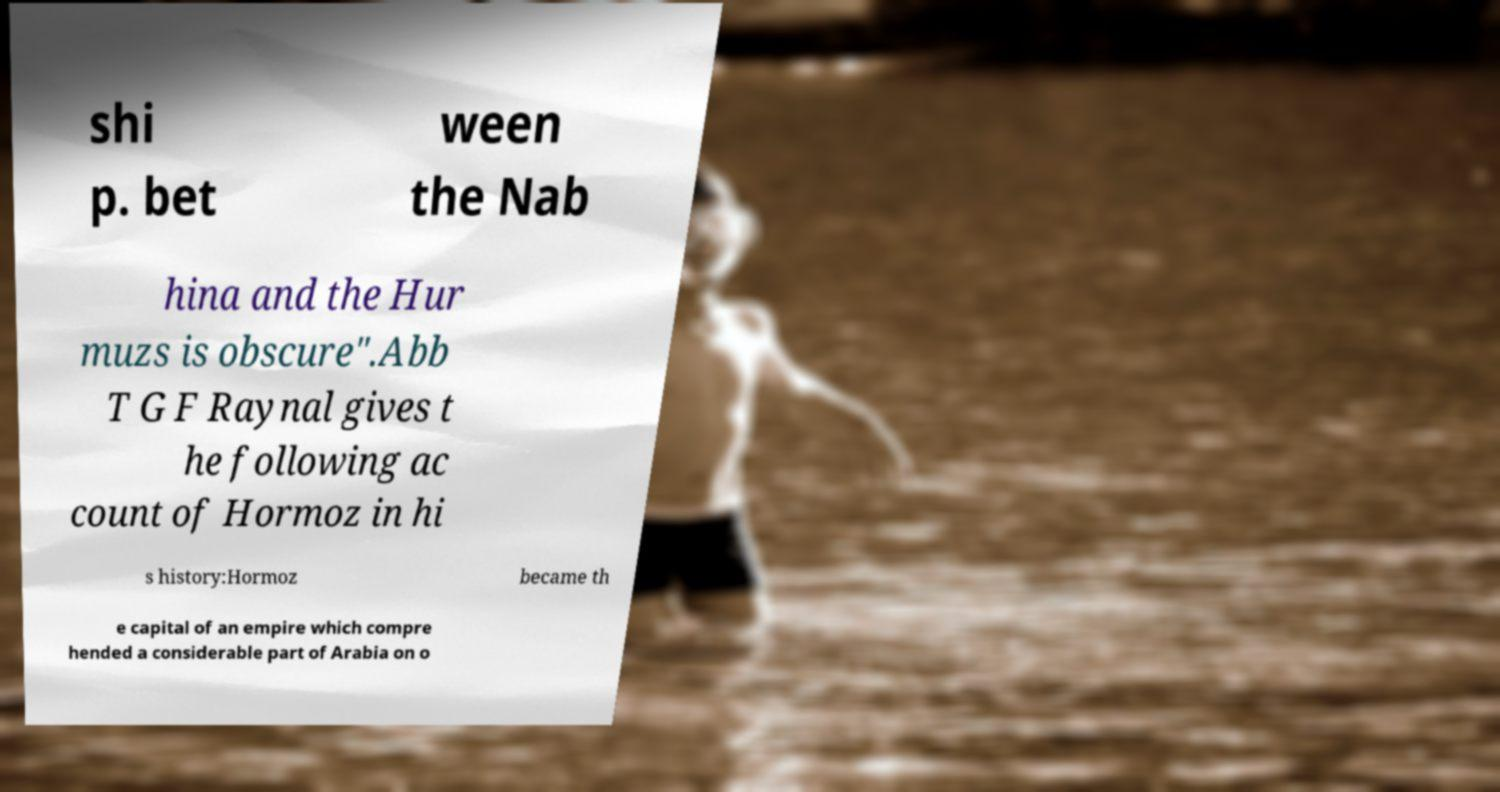Please identify and transcribe the text found in this image. shi p. bet ween the Nab hina and the Hur muzs is obscure".Abb T G F Raynal gives t he following ac count of Hormoz in hi s history:Hormoz became th e capital of an empire which compre hended a considerable part of Arabia on o 